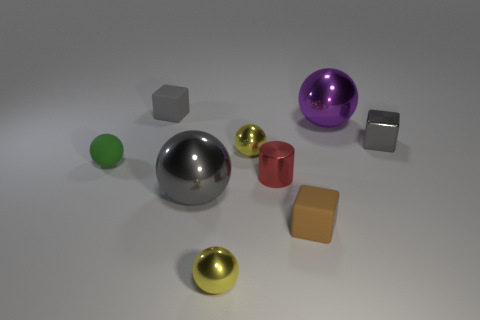Subtract all small matte spheres. How many spheres are left? 4 Subtract all green balls. How many balls are left? 4 Add 1 big brown matte cylinders. How many objects exist? 10 Subtract all gray spheres. Subtract all gray blocks. How many spheres are left? 4 Subtract all cylinders. How many objects are left? 8 Add 3 yellow objects. How many yellow objects are left? 5 Add 9 small brown metallic objects. How many small brown metallic objects exist? 9 Subtract 0 yellow cubes. How many objects are left? 9 Subtract all tiny metal spheres. Subtract all spheres. How many objects are left? 2 